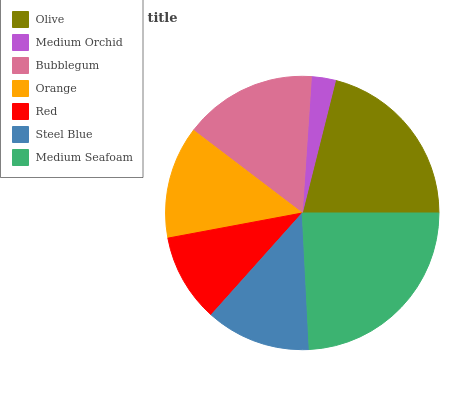Is Medium Orchid the minimum?
Answer yes or no. Yes. Is Medium Seafoam the maximum?
Answer yes or no. Yes. Is Bubblegum the minimum?
Answer yes or no. No. Is Bubblegum the maximum?
Answer yes or no. No. Is Bubblegum greater than Medium Orchid?
Answer yes or no. Yes. Is Medium Orchid less than Bubblegum?
Answer yes or no. Yes. Is Medium Orchid greater than Bubblegum?
Answer yes or no. No. Is Bubblegum less than Medium Orchid?
Answer yes or no. No. Is Orange the high median?
Answer yes or no. Yes. Is Orange the low median?
Answer yes or no. Yes. Is Medium Seafoam the high median?
Answer yes or no. No. Is Bubblegum the low median?
Answer yes or no. No. 